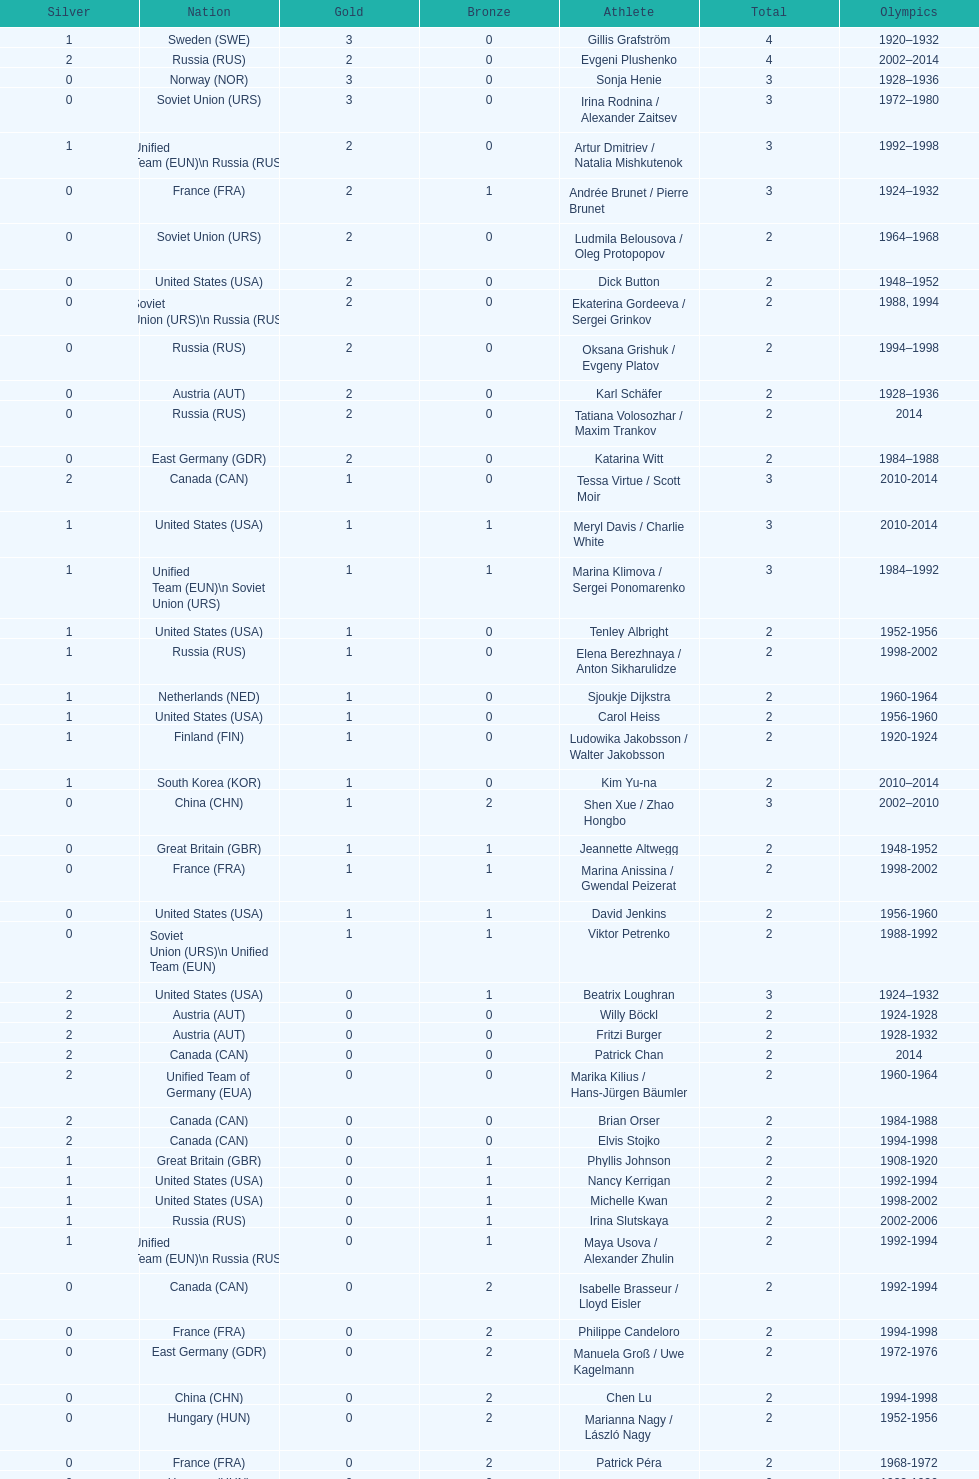Which athlete was from south korea after the year 2010? Kim Yu-na. 